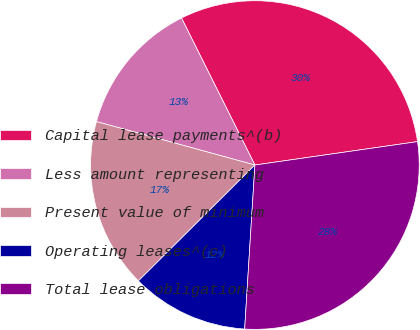Convert chart. <chart><loc_0><loc_0><loc_500><loc_500><pie_chart><fcel>Capital lease payments^(b)<fcel>Less amount representing<fcel>Present value of minimum<fcel>Operating leases^(c)<fcel>Total lease obligations<nl><fcel>30.09%<fcel>13.37%<fcel>16.72%<fcel>11.55%<fcel>28.27%<nl></chart> 